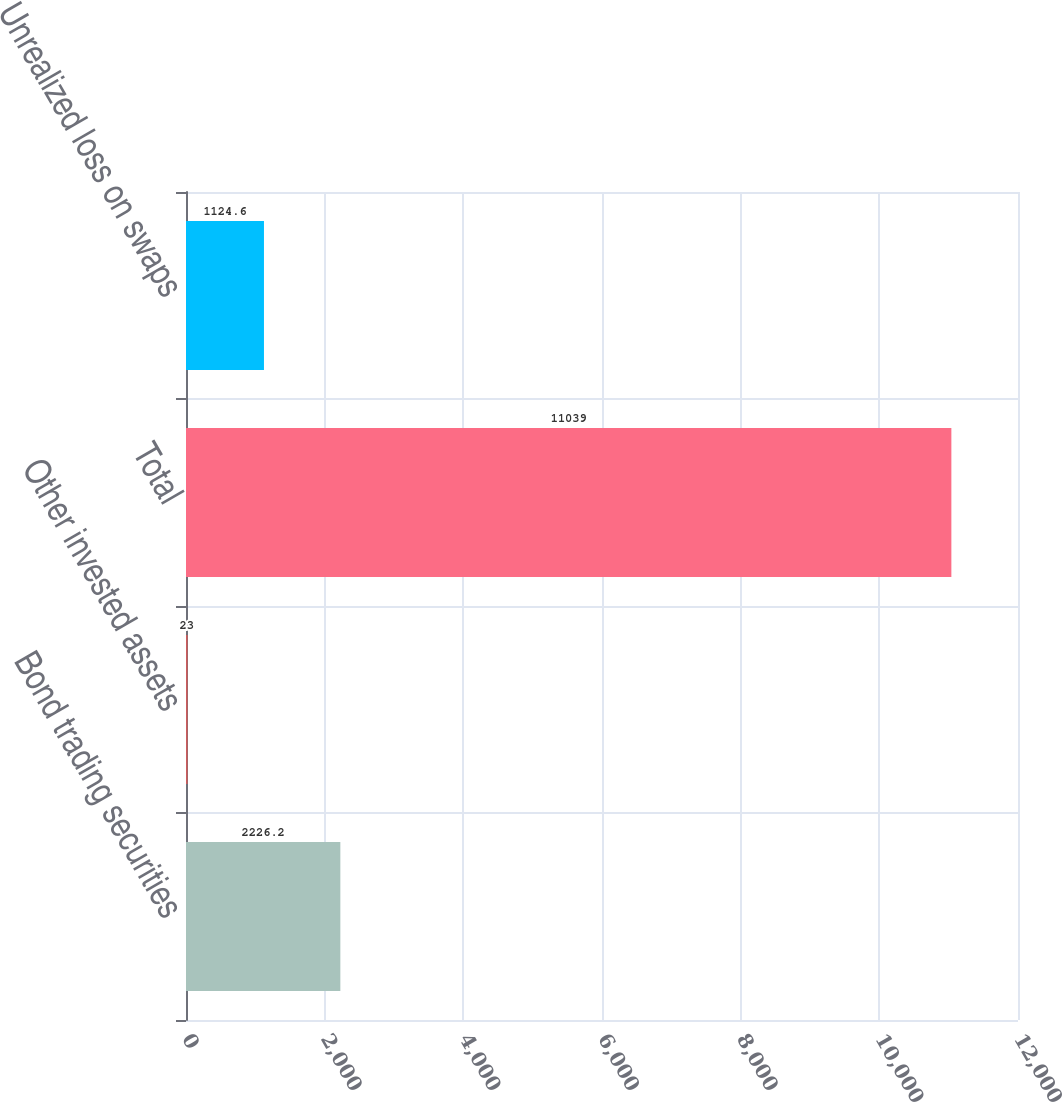Convert chart. <chart><loc_0><loc_0><loc_500><loc_500><bar_chart><fcel>Bond trading securities<fcel>Other invested assets<fcel>Total<fcel>Unrealized loss on swaps<nl><fcel>2226.2<fcel>23<fcel>11039<fcel>1124.6<nl></chart> 